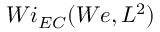<formula> <loc_0><loc_0><loc_500><loc_500>W i _ { E C } ( W e , L ^ { 2 } )</formula> 